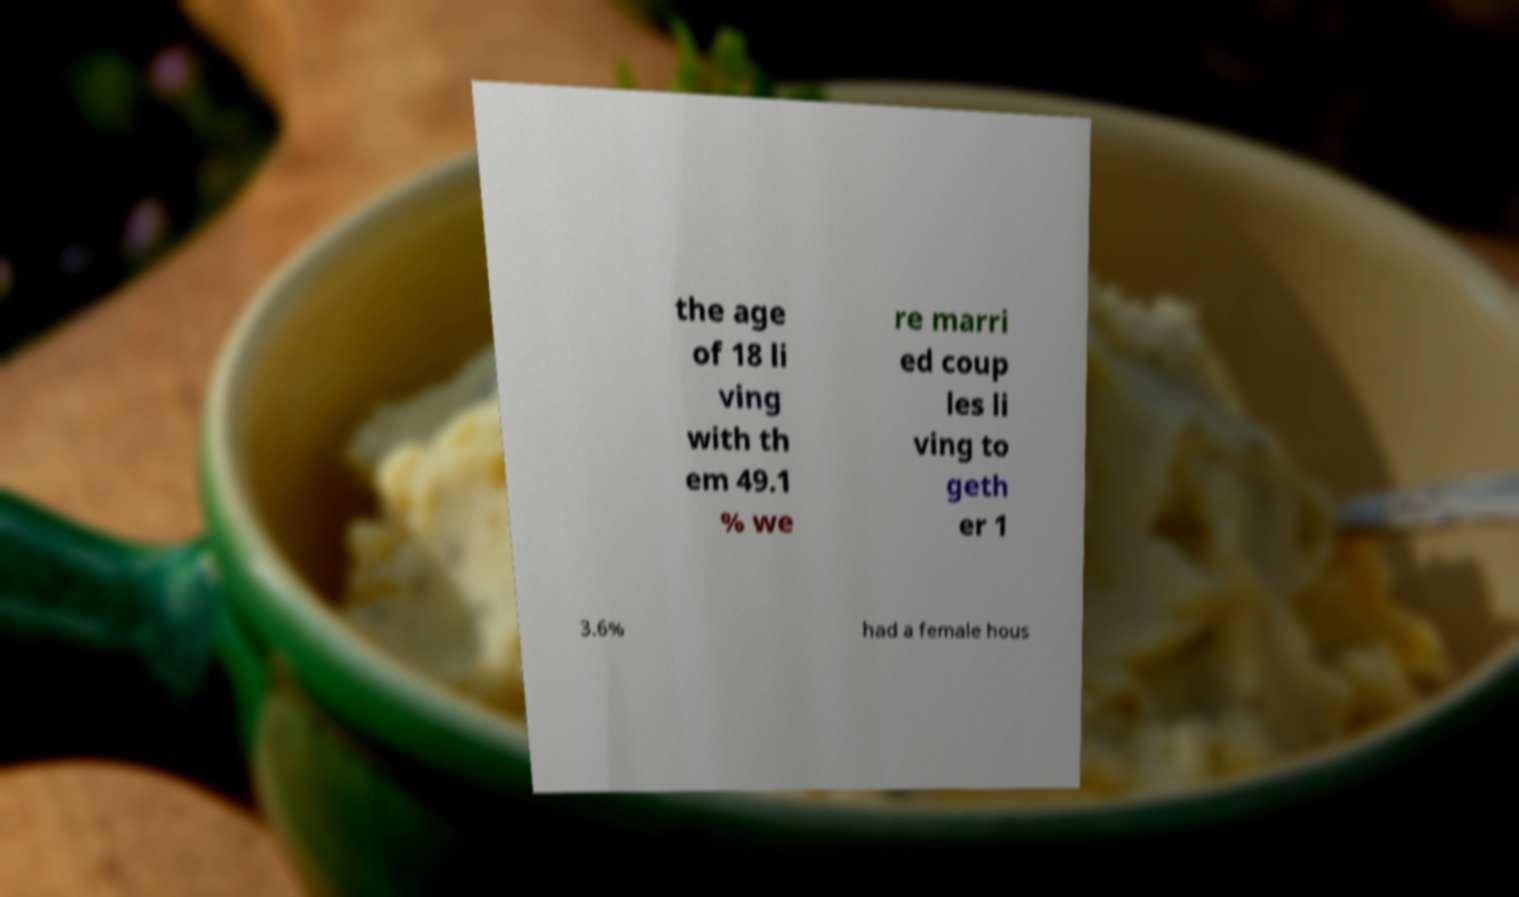Could you extract and type out the text from this image? the age of 18 li ving with th em 49.1 % we re marri ed coup les li ving to geth er 1 3.6% had a female hous 